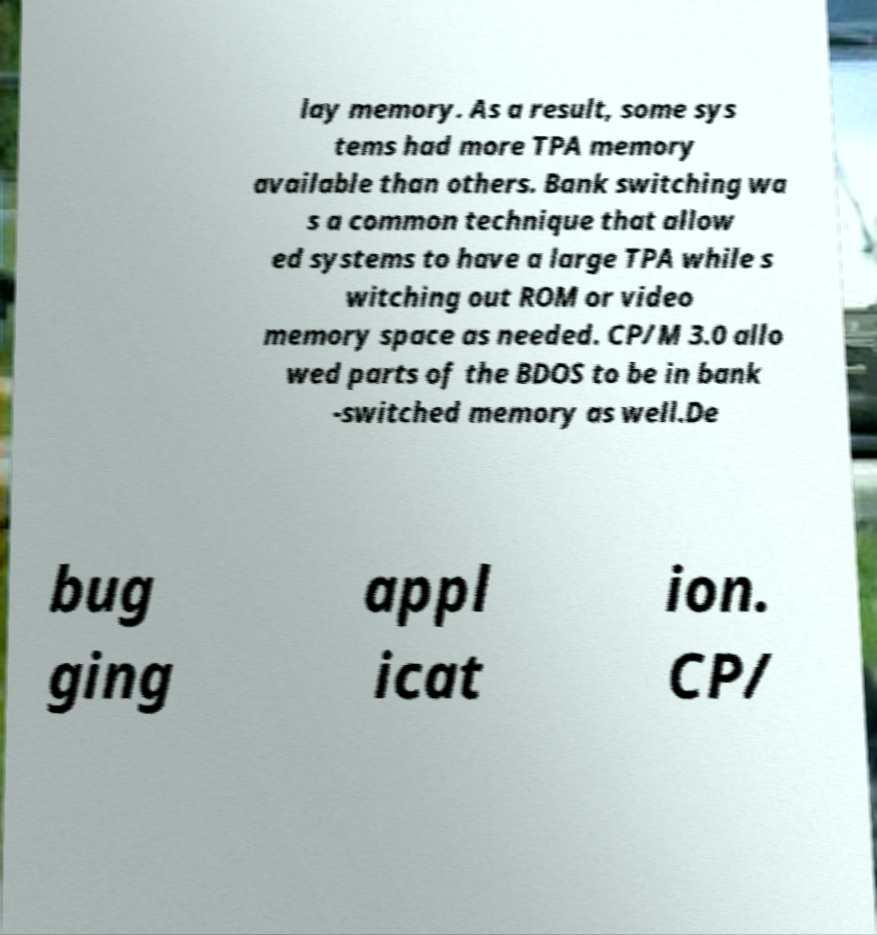For documentation purposes, I need the text within this image transcribed. Could you provide that? lay memory. As a result, some sys tems had more TPA memory available than others. Bank switching wa s a common technique that allow ed systems to have a large TPA while s witching out ROM or video memory space as needed. CP/M 3.0 allo wed parts of the BDOS to be in bank -switched memory as well.De bug ging appl icat ion. CP/ 